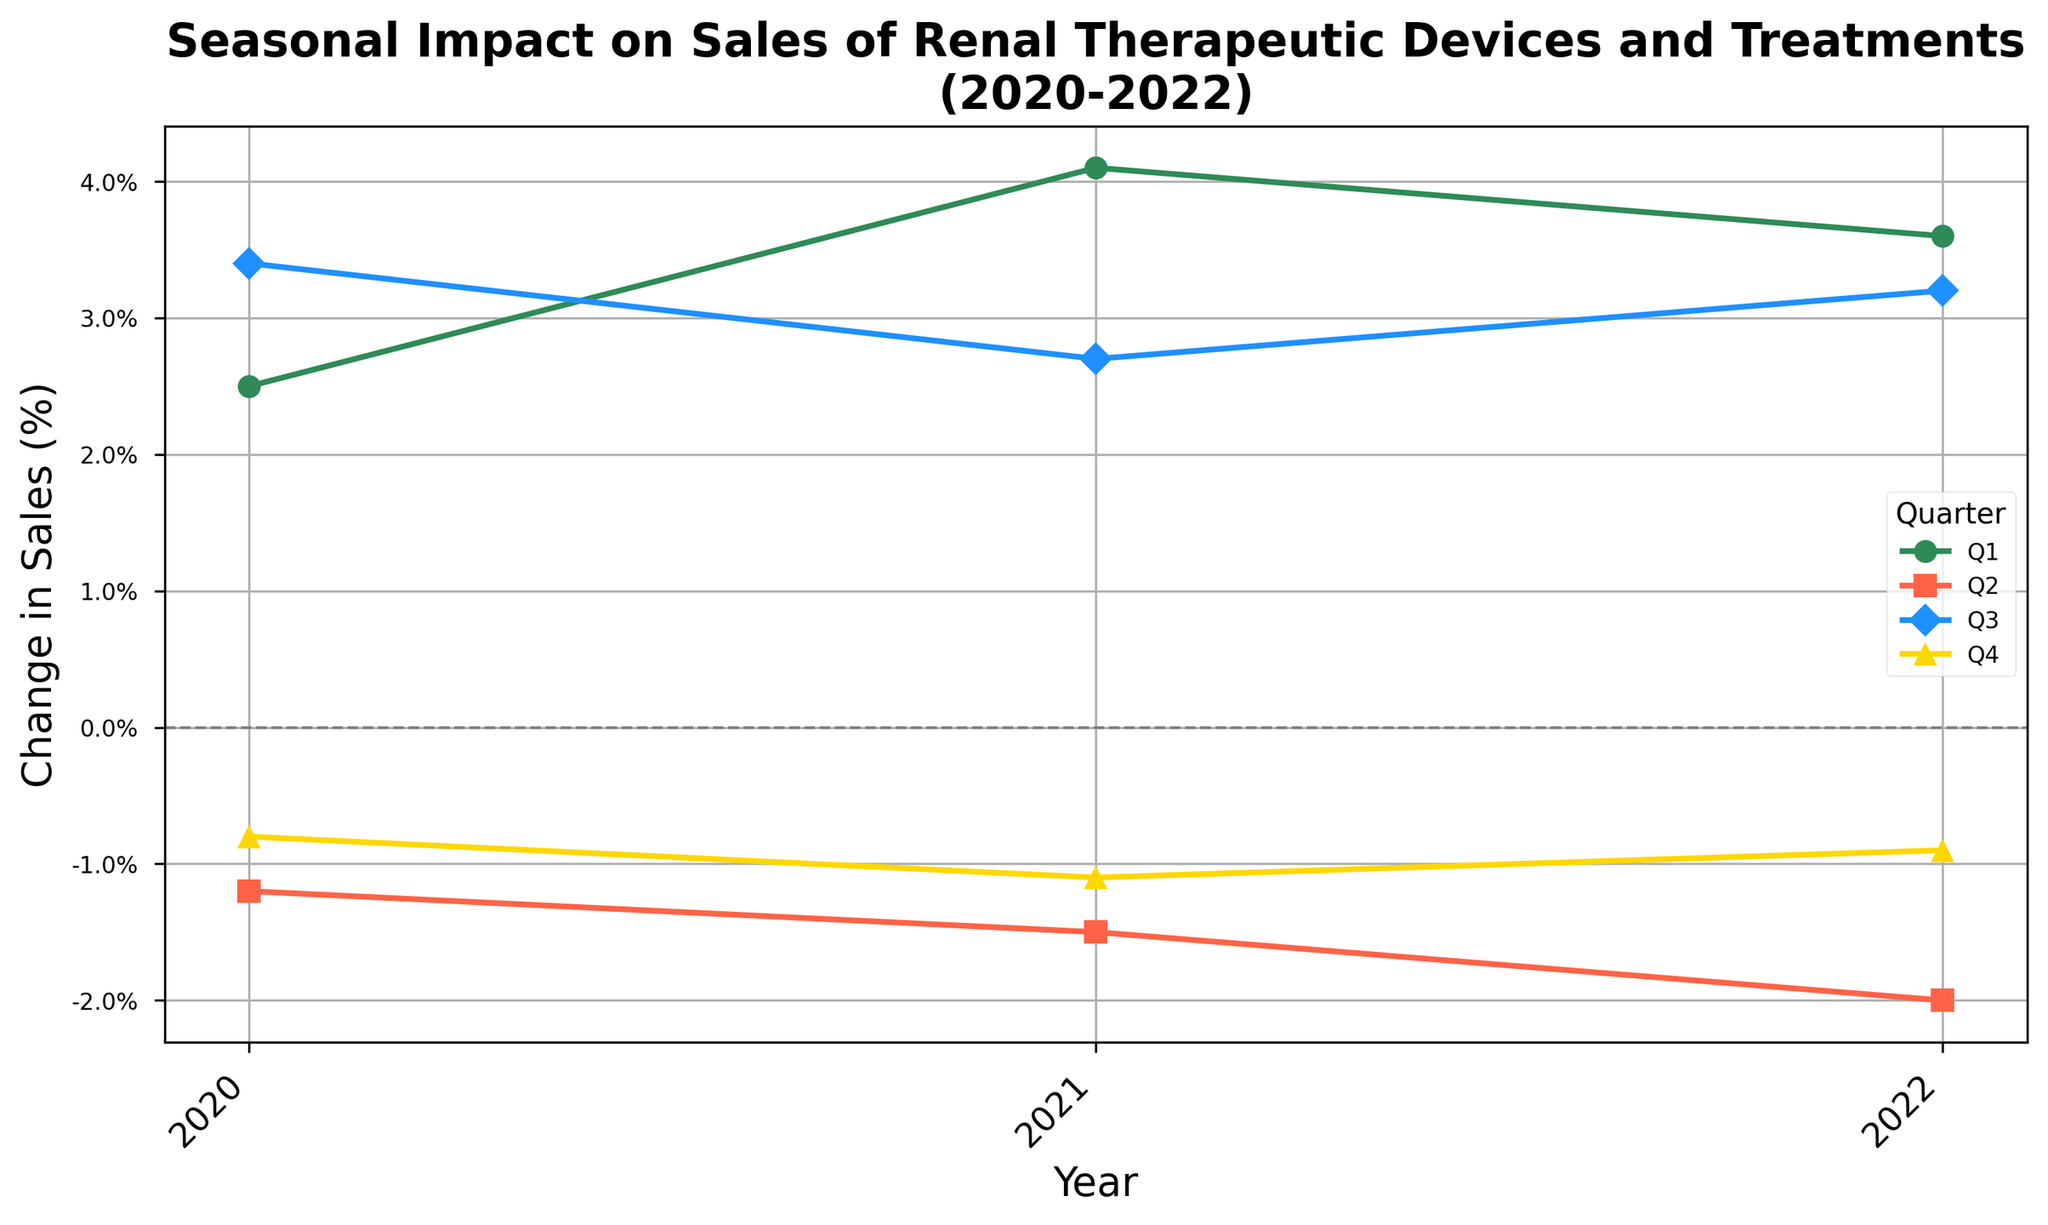What was the highest quarterly increase in sales over the three-year period? The highest increase can be found by comparing all quarterly `Change in Sales (%)` values. The highest value is 4.1% in Q1 2021.
Answer: 4.1% Which quarter consistently showed a negative change in sales over the three years? By observing the graph and identifying which lines dip below zero consecutively, we can see that Q2 shows negative changes in sales for each year: -1.2%, -1.5%, and -2.0%.
Answer: Q2 Which year had the highest overall sum of quarterly sales changes? To find the sum for each year, add the quarterly changes for each year. 
2020: 2.5 - 1.2 + 3.4 - 0.8 = 3.9 
2021: 4.1 - 1.5 + 2.7 - 1.1 = 4.2 
2022: 3.6 - 2.0 + 3.2 - 0.9 = 3.9 
2021 has the highest sum.
Answer: 2021 Which quarter showed the most fluctuation in sales changes over the period? Calculate the range (max minus min) of sales changes for each quarter:
Q1: 4.1 - 2.5 = 1.6 
Q2: -1.2 - (-2.0) = 0.8 
Q3: 3.4 - 2.7 = 0.7 
Q4: -0.8 - (-1.1) = 0.3
Therefore, Q1 has the most fluctuation with a range of 1.6%.
Answer: Q1 How many quarters showed a positive change in sales during 2021? Count the number of quarters with positive values in 2021: Q1 (4.1), Q3 (2.7). Two quarters showed positive changes.
Answer: 2 Comparing Q1 and Q4 of 2021, which had a higher change in sales? Look at the Q1 and Q4 values for 2021. Q1 is 4.1%, and Q4 is -1.1%. Hence, Q1 had a higher change.
Answer: Q1 What is the average change in sales for Q3 over the three years? Calculate the average by summing the Q3 changes and dividing by the number of years: (3.4 + 2.7 + 3.2) / 3 = 3.1%
Answer: 3.1% Was there any quarter in 2022 that experienced a consistent increase in sales compared to the same quarters in previous years? Analyzing each quarter in 2022 compared to 2020 and 2021:
- Q1: 3.6 > 2.5 (2020) but < 4.1 (2021) 
- Q2: -2.0 < -1.2 (2020) and < -1.5 (2021) 
- Q3: 3.2 < 3.4 (2020) but > 2.7 (2021) 
- Q4: -0.9 > -0.8 (2020) and > -1.1 (2021)
Thus, no quarter consistently increased.
Answer: No 